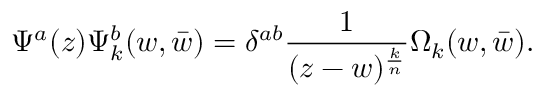Convert formula to latex. <formula><loc_0><loc_0><loc_500><loc_500>\Psi ^ { a } ( z ) \Psi _ { k } ^ { b } ( w , \bar { w } ) = \delta ^ { a b } { \frac { 1 } { ( z - w ) ^ { \frac { k } { n } } } } \Omega _ { k } ( w , \bar { w } ) .</formula> 